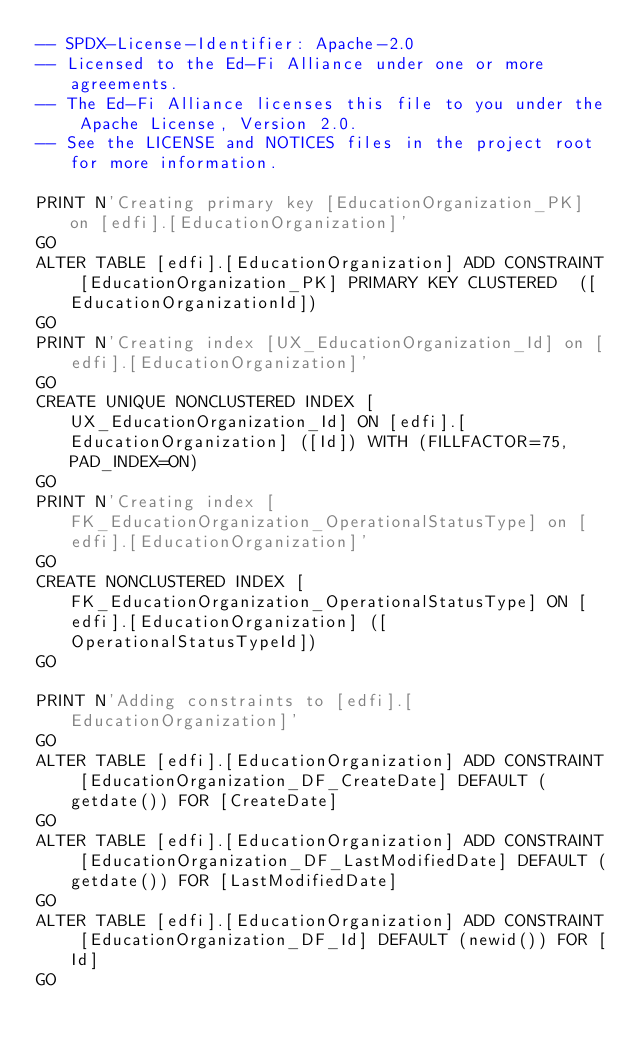Convert code to text. <code><loc_0><loc_0><loc_500><loc_500><_SQL_>-- SPDX-License-Identifier: Apache-2.0
-- Licensed to the Ed-Fi Alliance under one or more agreements.
-- The Ed-Fi Alliance licenses this file to you under the Apache License, Version 2.0.
-- See the LICENSE and NOTICES files in the project root for more information.

PRINT N'Creating primary key [EducationOrganization_PK] on [edfi].[EducationOrganization]'
GO
ALTER TABLE [edfi].[EducationOrganization] ADD CONSTRAINT [EducationOrganization_PK] PRIMARY KEY CLUSTERED  ([EducationOrganizationId])
GO
PRINT N'Creating index [UX_EducationOrganization_Id] on [edfi].[EducationOrganization]'
GO
CREATE UNIQUE NONCLUSTERED INDEX [UX_EducationOrganization_Id] ON [edfi].[EducationOrganization] ([Id]) WITH (FILLFACTOR=75, PAD_INDEX=ON)
GO
PRINT N'Creating index [FK_EducationOrganization_OperationalStatusType] on [edfi].[EducationOrganization]'
GO
CREATE NONCLUSTERED INDEX [FK_EducationOrganization_OperationalStatusType] ON [edfi].[EducationOrganization] ([OperationalStatusTypeId])
GO

PRINT N'Adding constraints to [edfi].[EducationOrganization]'
GO
ALTER TABLE [edfi].[EducationOrganization] ADD CONSTRAINT [EducationOrganization_DF_CreateDate] DEFAULT (getdate()) FOR [CreateDate]
GO
ALTER TABLE [edfi].[EducationOrganization] ADD CONSTRAINT [EducationOrganization_DF_LastModifiedDate] DEFAULT (getdate()) FOR [LastModifiedDate]
GO
ALTER TABLE [edfi].[EducationOrganization] ADD CONSTRAINT [EducationOrganization_DF_Id] DEFAULT (newid()) FOR [Id]
GO

</code> 